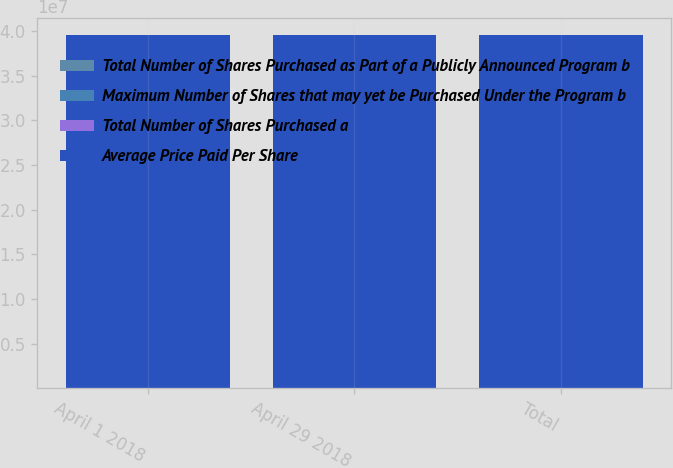Convert chart to OTSL. <chart><loc_0><loc_0><loc_500><loc_500><stacked_bar_chart><ecel><fcel>April 1 2018<fcel>April 29 2018<fcel>Total<nl><fcel>Total Number of Shares Purchased as Part of a Publicly Announced Program b<fcel>250<fcel>9437<fcel>9687<nl><fcel>Maximum Number of Shares that may yet be Purchased Under the Program b<fcel>50.57<fcel>45.06<fcel>45.2<nl><fcel>Total Number of Shares Purchased a<fcel>250<fcel>9437<fcel>9687<nl><fcel>Average Price Paid Per Share<fcel>3.9525e+07<fcel>3.95156e+07<fcel>3.95156e+07<nl></chart> 